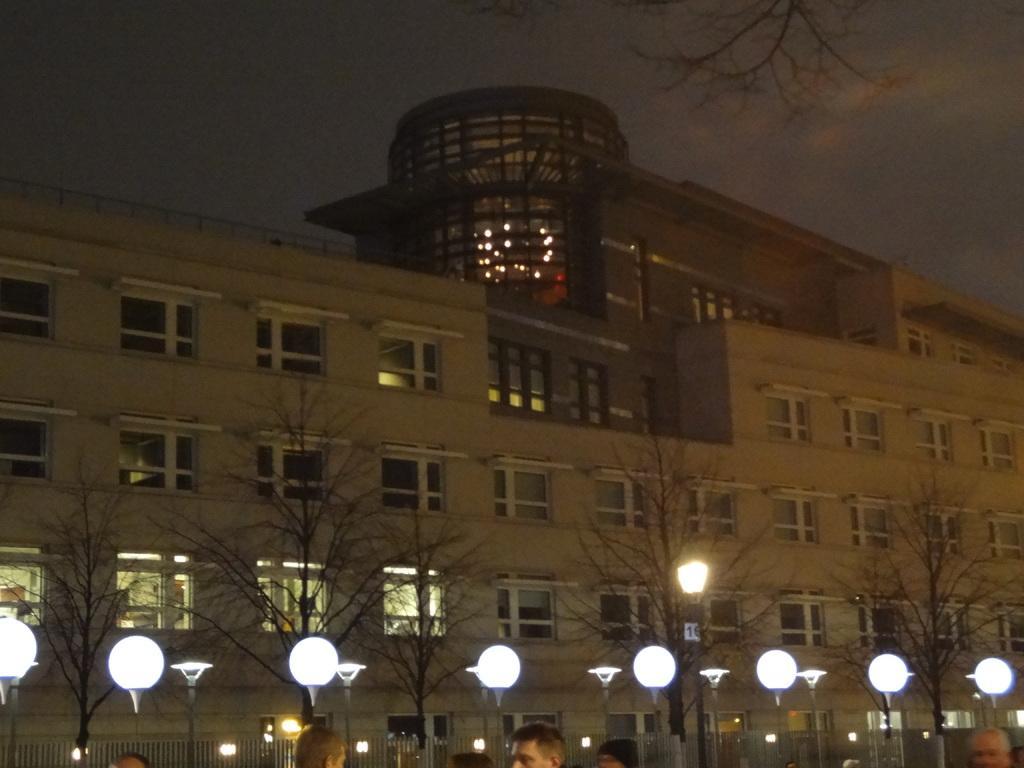Can you describe this image briefly? In the image there is a building in the back with many windows all over it with street lights and trees in front of it and above its sky with clouds, this is clicked at night time. 